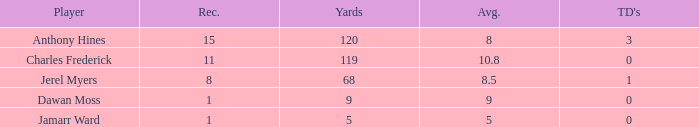What is the total Avg when TDs are 0 and Dawan Moss is a player? 0.0. 